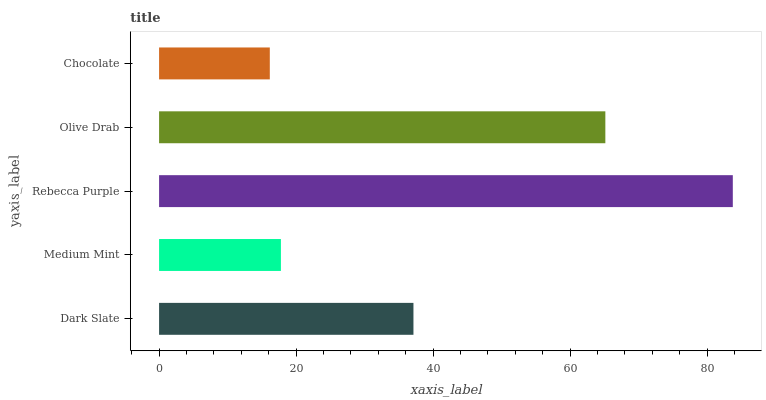Is Chocolate the minimum?
Answer yes or no. Yes. Is Rebecca Purple the maximum?
Answer yes or no. Yes. Is Medium Mint the minimum?
Answer yes or no. No. Is Medium Mint the maximum?
Answer yes or no. No. Is Dark Slate greater than Medium Mint?
Answer yes or no. Yes. Is Medium Mint less than Dark Slate?
Answer yes or no. Yes. Is Medium Mint greater than Dark Slate?
Answer yes or no. No. Is Dark Slate less than Medium Mint?
Answer yes or no. No. Is Dark Slate the high median?
Answer yes or no. Yes. Is Dark Slate the low median?
Answer yes or no. Yes. Is Medium Mint the high median?
Answer yes or no. No. Is Rebecca Purple the low median?
Answer yes or no. No. 